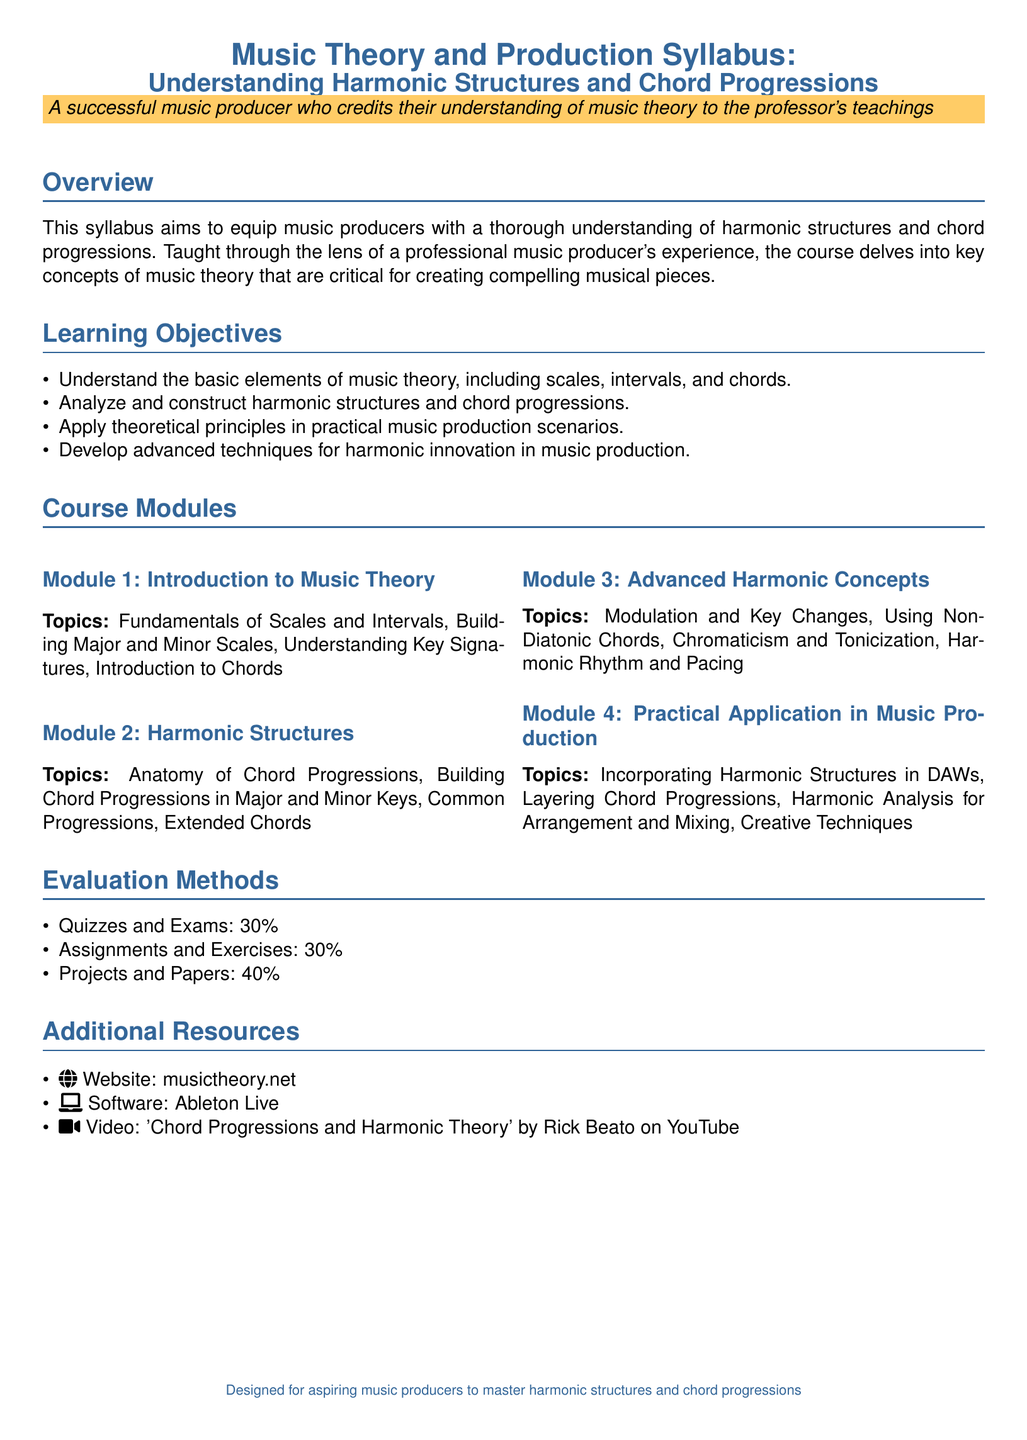What is the main focus of the syllabus? The syllabus aims to equip music producers with a thorough understanding of harmonic structures and chord progressions.
Answer: Harmonic structures and chord progressions What is the weight of quizzes and exams in the evaluation methods? The weight is specified in the document under Evaluation Methods.
Answer: 30% Which module covers fundamental music theory elements? This relates to the topics outlined in the Course Modules section, specifically the first module.
Answer: Module 1 What percentage of the assessment is from projects and papers? This information is detailed as part of the evaluation methods in the syllabus.
Answer: 40% What software is listed as a resource for the course? This information comes from the Additional Resources section of the syllabus.
Answer: Ableton Live What is the first topic in Module 2? The first topic listed in Module 2 relates to harmonic structures.
Answer: Anatomy of Chord Progressions Which video is recommended in the Additional Resources? The specific resource is mentioned in the Additional Resources section of the syllabus.
Answer: 'Chord Progressions and Harmonic Theory' by Rick Beato on YouTube What is included in the practical application module? The topics in this module are outlined in the Course Modules section.
Answer: Incorporating Harmonic Structures in DAWs What is the purpose of the syllabus? The purpose relates to its goal as described in the Overview section.
Answer: Master harmonic structures and chord progressions 